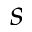<formula> <loc_0><loc_0><loc_500><loc_500>s</formula> 